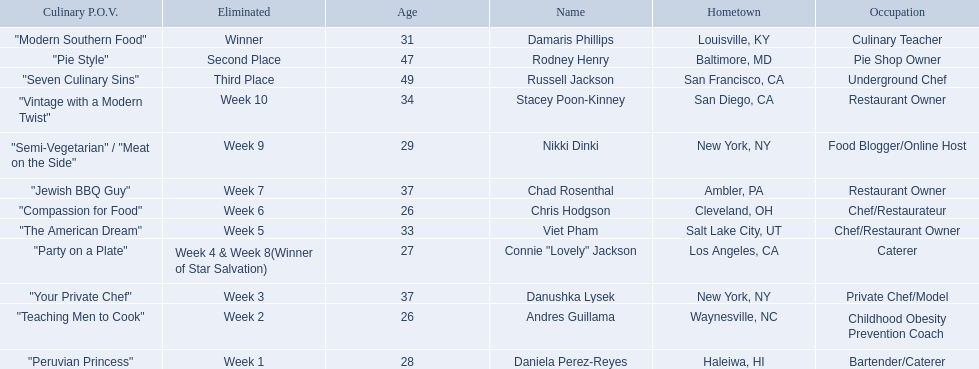Who are the listed food network star contestants? Damaris Phillips, Rodney Henry, Russell Jackson, Stacey Poon-Kinney, Nikki Dinki, Chad Rosenthal, Chris Hodgson, Viet Pham, Connie "Lovely" Jackson, Danushka Lysek, Andres Guillama, Daniela Perez-Reyes. Of those who had the longest p.o.v title? Nikki Dinki. 